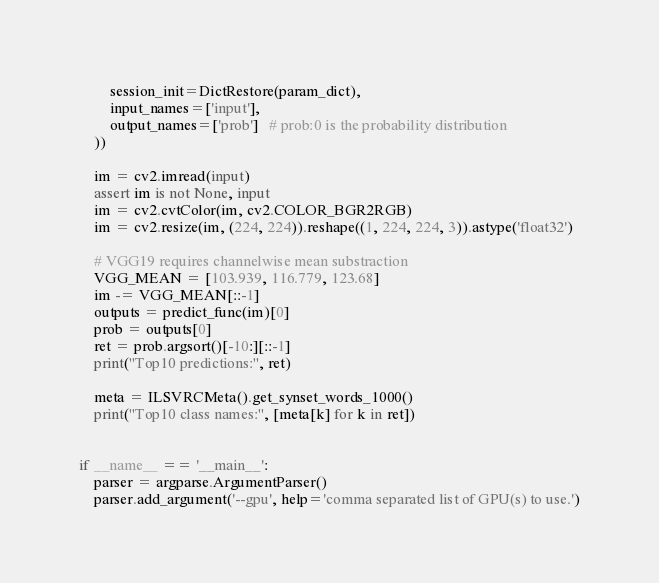<code> <loc_0><loc_0><loc_500><loc_500><_Python_>        session_init=DictRestore(param_dict),
        input_names=['input'],
        output_names=['prob']   # prob:0 is the probability distribution
    ))

    im = cv2.imread(input)
    assert im is not None, input
    im = cv2.cvtColor(im, cv2.COLOR_BGR2RGB)
    im = cv2.resize(im, (224, 224)).reshape((1, 224, 224, 3)).astype('float32')

    # VGG19 requires channelwise mean substraction
    VGG_MEAN = [103.939, 116.779, 123.68]
    im -= VGG_MEAN[::-1]
    outputs = predict_func(im)[0]
    prob = outputs[0]
    ret = prob.argsort()[-10:][::-1]
    print("Top10 predictions:", ret)

    meta = ILSVRCMeta().get_synset_words_1000()
    print("Top10 class names:", [meta[k] for k in ret])


if __name__ == '__main__':
    parser = argparse.ArgumentParser()
    parser.add_argument('--gpu', help='comma separated list of GPU(s) to use.')</code> 